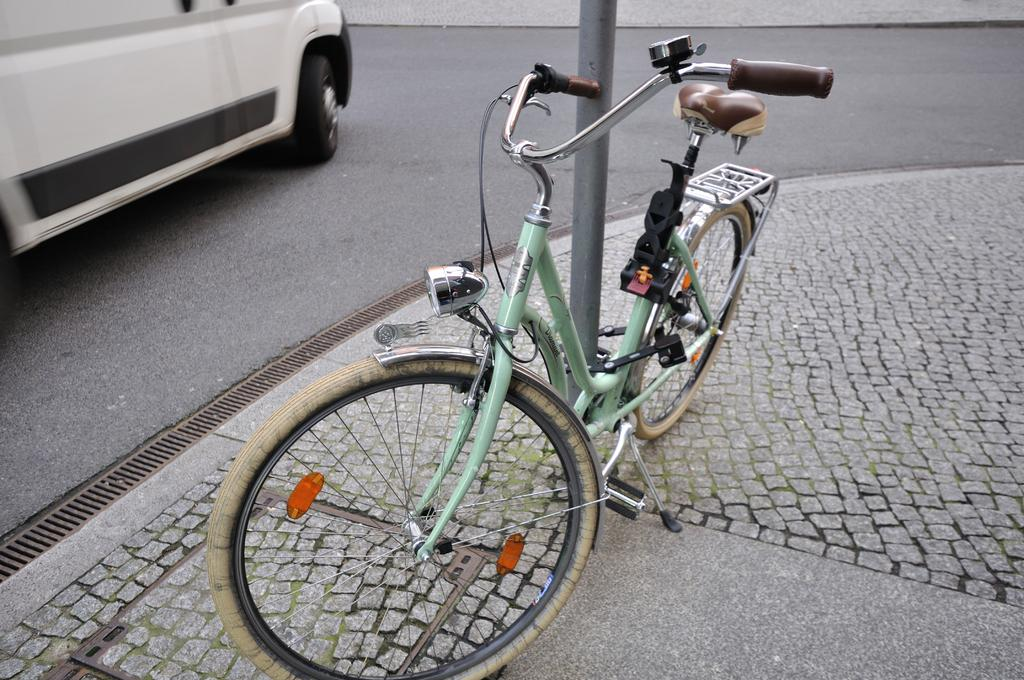What type of transportation is present in the image? There is a vehicle in the image. What other mode of transportation can be seen in the image? There is a bicycle in the image. What object is standing upright in the image? There is a pole in the image. What surface is visible in the image? The ground is visible in the image. Where is the office located in the image? There is no office present in the image. What type of match is being played in the image? There is no match being played in the image. 